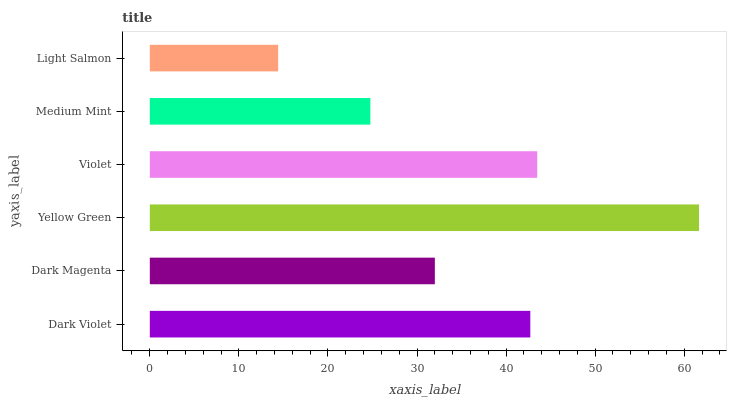Is Light Salmon the minimum?
Answer yes or no. Yes. Is Yellow Green the maximum?
Answer yes or no. Yes. Is Dark Magenta the minimum?
Answer yes or no. No. Is Dark Magenta the maximum?
Answer yes or no. No. Is Dark Violet greater than Dark Magenta?
Answer yes or no. Yes. Is Dark Magenta less than Dark Violet?
Answer yes or no. Yes. Is Dark Magenta greater than Dark Violet?
Answer yes or no. No. Is Dark Violet less than Dark Magenta?
Answer yes or no. No. Is Dark Violet the high median?
Answer yes or no. Yes. Is Dark Magenta the low median?
Answer yes or no. Yes. Is Yellow Green the high median?
Answer yes or no. No. Is Yellow Green the low median?
Answer yes or no. No. 